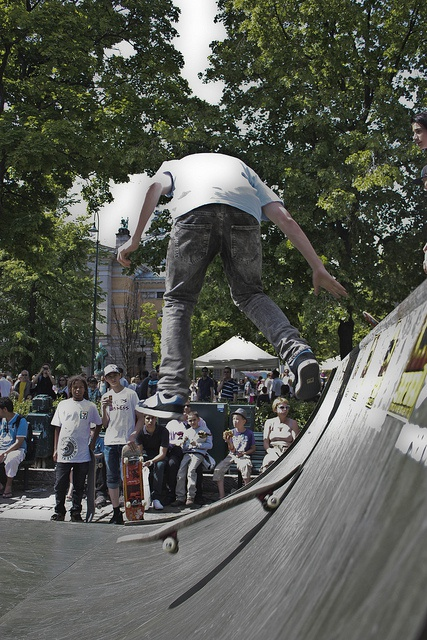Describe the objects in this image and their specific colors. I can see people in olive, black, gray, lightgray, and darkgray tones, people in olive, black, darkgray, and gray tones, skateboard in olive, darkgray, gray, and black tones, people in olive, darkgray, black, and gray tones, and people in olive, black, gray, and darkgray tones in this image. 